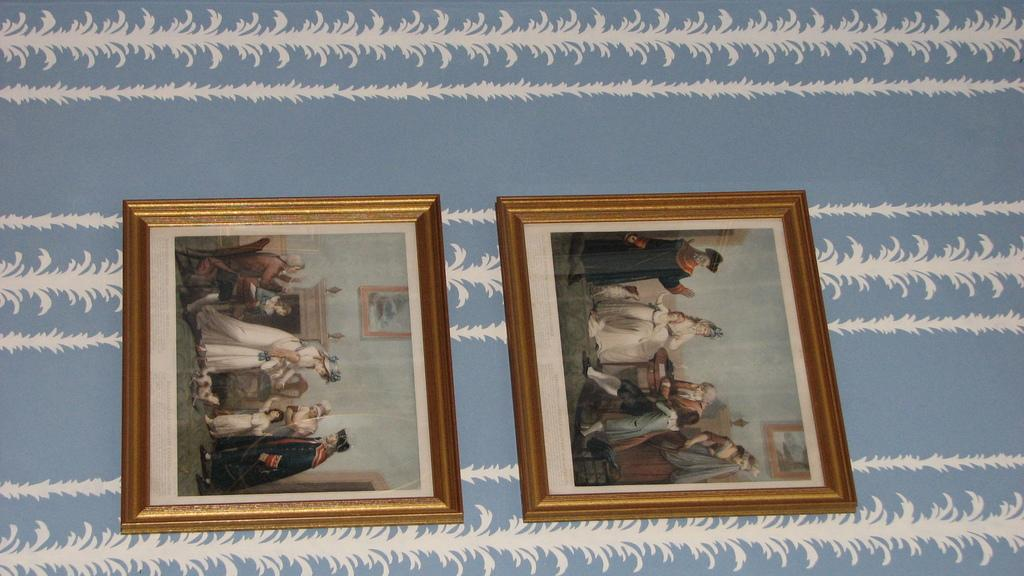How many photo frames can be seen in the image? There are two photo frames in the image. Where are the photo frames located? The photo frames are on the wall. What type of representative is present in the image? There is no representative present in the image; it only features two photo frames on the wall. 